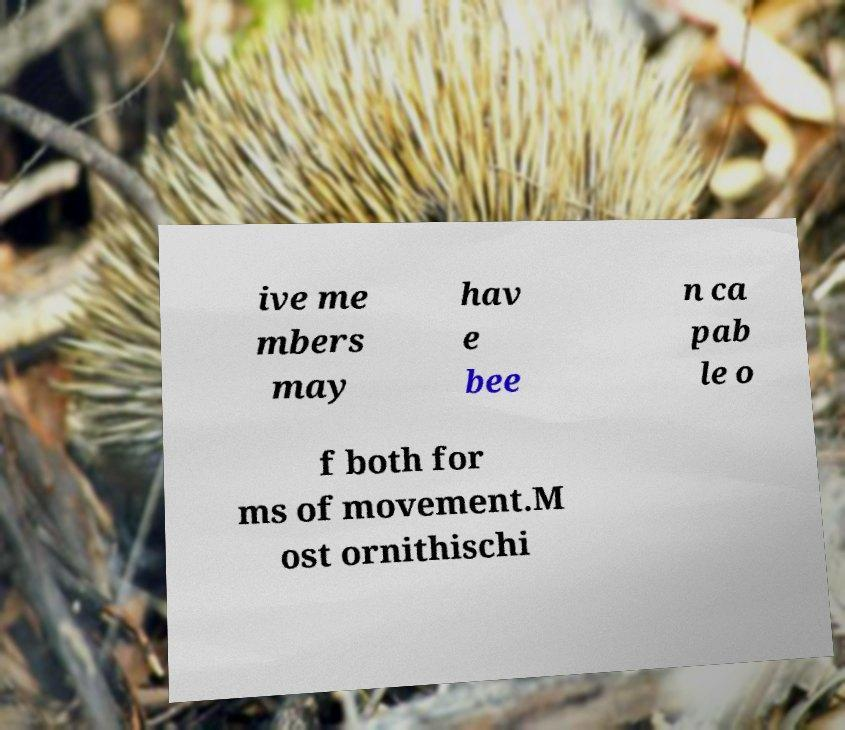Can you read and provide the text displayed in the image?This photo seems to have some interesting text. Can you extract and type it out for me? ive me mbers may hav e bee n ca pab le o f both for ms of movement.M ost ornithischi 